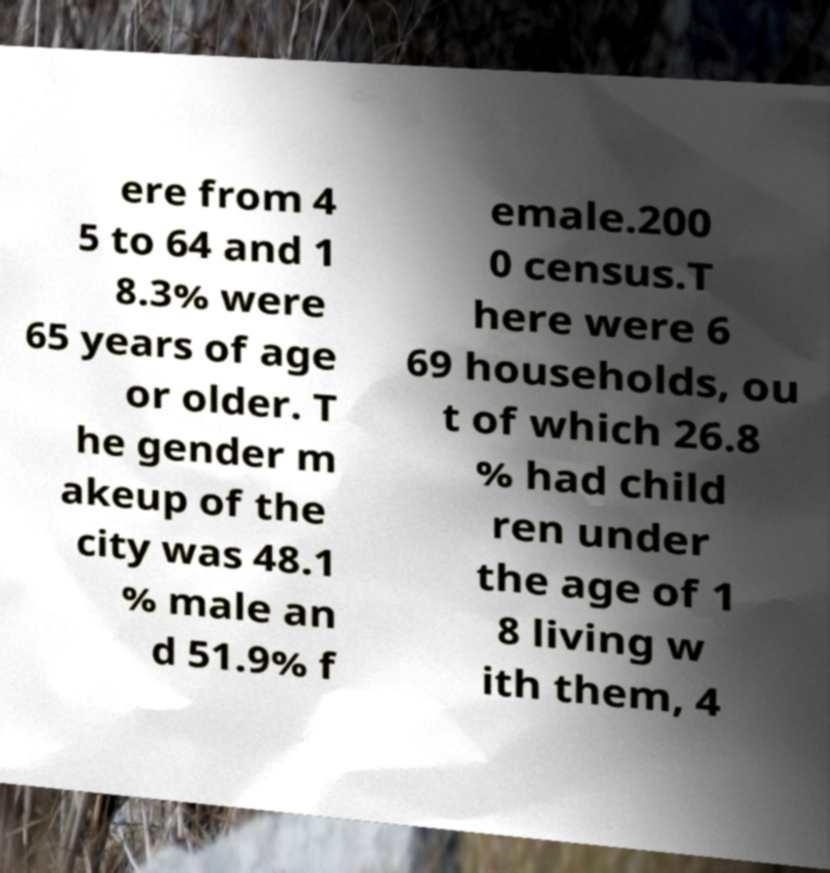There's text embedded in this image that I need extracted. Can you transcribe it verbatim? ere from 4 5 to 64 and 1 8.3% were 65 years of age or older. T he gender m akeup of the city was 48.1 % male an d 51.9% f emale.200 0 census.T here were 6 69 households, ou t of which 26.8 % had child ren under the age of 1 8 living w ith them, 4 